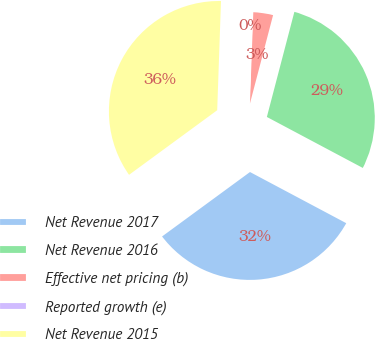<chart> <loc_0><loc_0><loc_500><loc_500><pie_chart><fcel>Net Revenue 2017<fcel>Net Revenue 2016<fcel>Effective net pricing (b)<fcel>Reported growth (e)<fcel>Net Revenue 2015<nl><fcel>32.16%<fcel>28.7%<fcel>3.49%<fcel>0.03%<fcel>35.62%<nl></chart> 